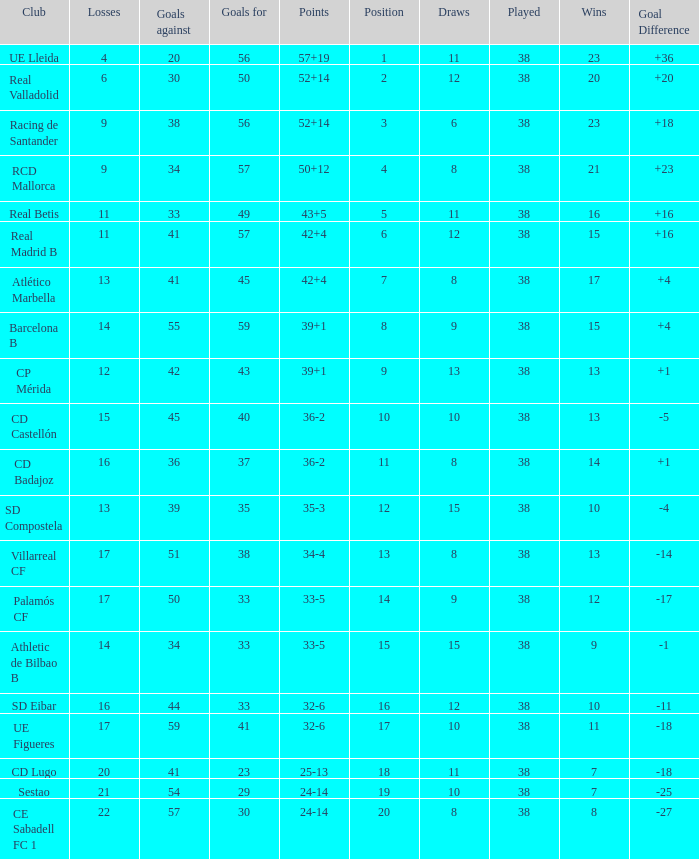What is the highest number of loss with a 7 position and more than 45 goals? None. 